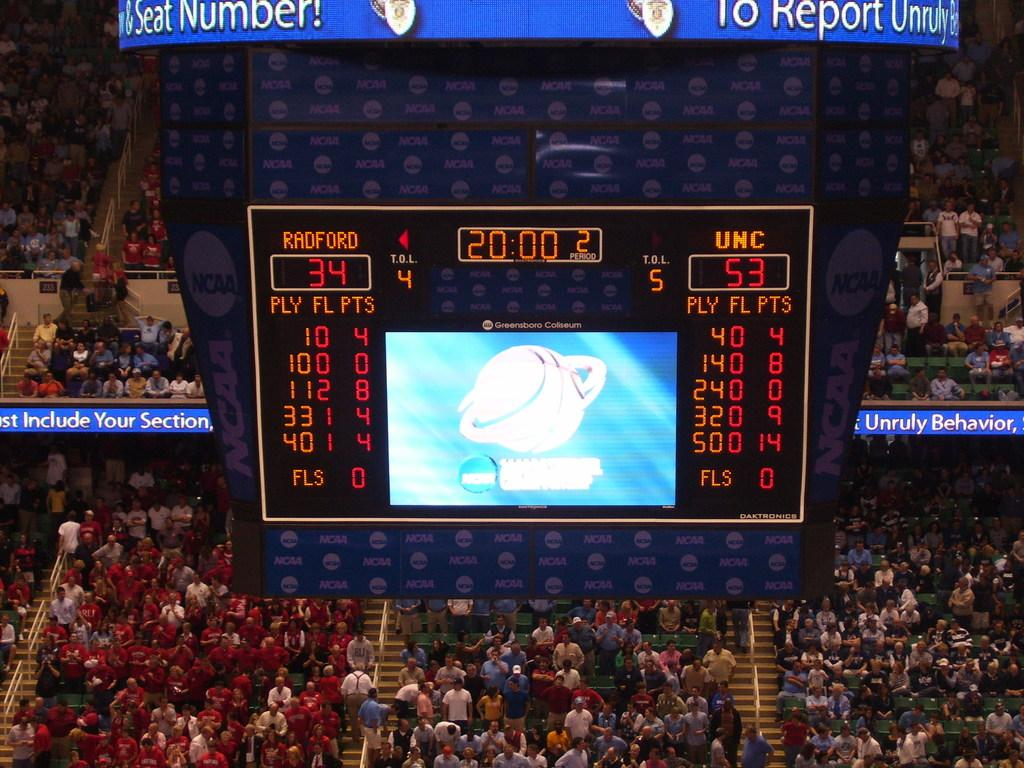<image>
Present a compact description of the photo's key features. A scoreboard for the game between Radford and UNC is hanging from ceiling in the arena. 